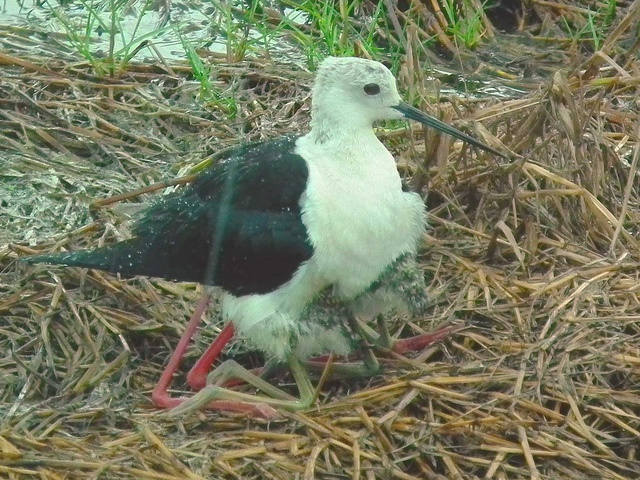Describe the objects in this image and their specific colors. I can see a bird in aquamarine, black, gray, beige, and darkgray tones in this image. 